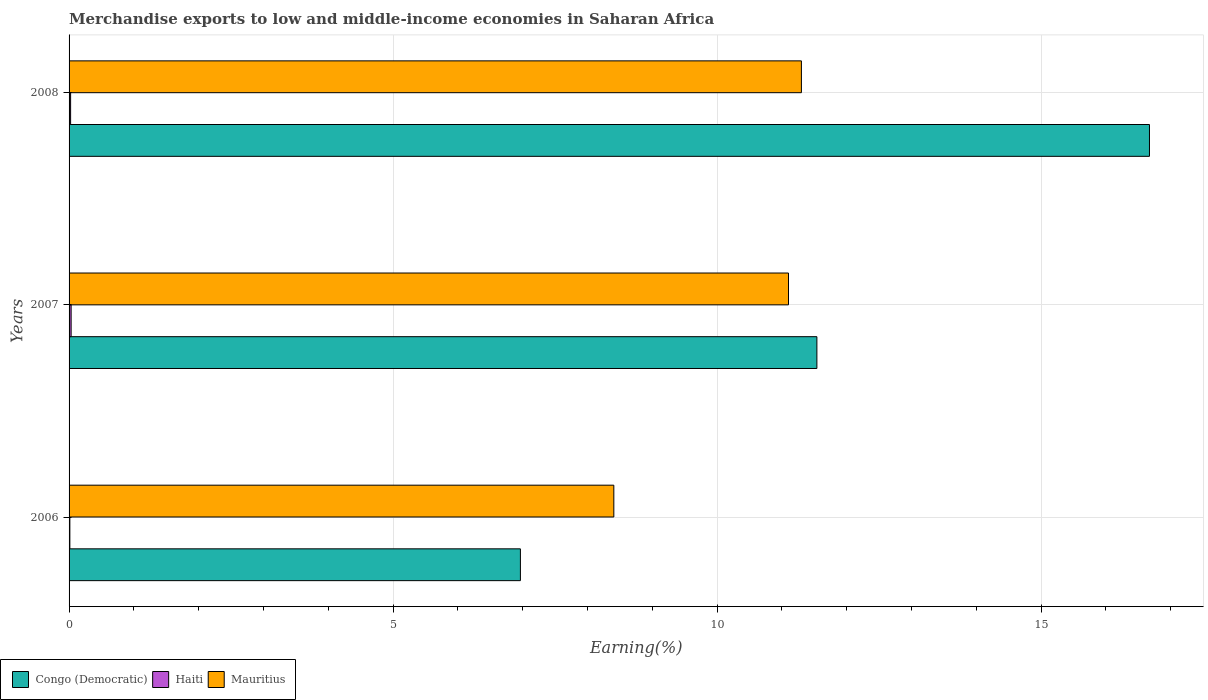Are the number of bars on each tick of the Y-axis equal?
Provide a succinct answer. Yes. How many bars are there on the 1st tick from the bottom?
Offer a very short reply. 3. What is the label of the 3rd group of bars from the top?
Make the answer very short. 2006. In how many cases, is the number of bars for a given year not equal to the number of legend labels?
Ensure brevity in your answer.  0. What is the percentage of amount earned from merchandise exports in Congo (Democratic) in 2008?
Your response must be concise. 16.67. Across all years, what is the maximum percentage of amount earned from merchandise exports in Mauritius?
Keep it short and to the point. 11.3. Across all years, what is the minimum percentage of amount earned from merchandise exports in Mauritius?
Offer a very short reply. 8.41. In which year was the percentage of amount earned from merchandise exports in Haiti maximum?
Give a very brief answer. 2007. In which year was the percentage of amount earned from merchandise exports in Haiti minimum?
Provide a succinct answer. 2006. What is the total percentage of amount earned from merchandise exports in Haiti in the graph?
Offer a very short reply. 0.07. What is the difference between the percentage of amount earned from merchandise exports in Congo (Democratic) in 2007 and that in 2008?
Your response must be concise. -5.13. What is the difference between the percentage of amount earned from merchandise exports in Mauritius in 2006 and the percentage of amount earned from merchandise exports in Haiti in 2008?
Offer a terse response. 8.38. What is the average percentage of amount earned from merchandise exports in Mauritius per year?
Make the answer very short. 10.27. In the year 2008, what is the difference between the percentage of amount earned from merchandise exports in Mauritius and percentage of amount earned from merchandise exports in Congo (Democratic)?
Make the answer very short. -5.37. In how many years, is the percentage of amount earned from merchandise exports in Haiti greater than 15 %?
Offer a terse response. 0. What is the ratio of the percentage of amount earned from merchandise exports in Congo (Democratic) in 2007 to that in 2008?
Offer a terse response. 0.69. Is the percentage of amount earned from merchandise exports in Mauritius in 2006 less than that in 2008?
Your answer should be compact. Yes. Is the difference between the percentage of amount earned from merchandise exports in Mauritius in 2006 and 2007 greater than the difference between the percentage of amount earned from merchandise exports in Congo (Democratic) in 2006 and 2007?
Keep it short and to the point. Yes. What is the difference between the highest and the second highest percentage of amount earned from merchandise exports in Congo (Democratic)?
Your response must be concise. 5.13. What is the difference between the highest and the lowest percentage of amount earned from merchandise exports in Congo (Democratic)?
Provide a succinct answer. 9.71. In how many years, is the percentage of amount earned from merchandise exports in Congo (Democratic) greater than the average percentage of amount earned from merchandise exports in Congo (Democratic) taken over all years?
Provide a succinct answer. 1. Is the sum of the percentage of amount earned from merchandise exports in Mauritius in 2007 and 2008 greater than the maximum percentage of amount earned from merchandise exports in Congo (Democratic) across all years?
Provide a succinct answer. Yes. What does the 2nd bar from the top in 2006 represents?
Your answer should be very brief. Haiti. What does the 1st bar from the bottom in 2006 represents?
Make the answer very short. Congo (Democratic). Are all the bars in the graph horizontal?
Offer a very short reply. Yes. Are the values on the major ticks of X-axis written in scientific E-notation?
Offer a terse response. No. Does the graph contain any zero values?
Your response must be concise. No. Does the graph contain grids?
Your answer should be compact. Yes. Where does the legend appear in the graph?
Your response must be concise. Bottom left. How many legend labels are there?
Your response must be concise. 3. What is the title of the graph?
Give a very brief answer. Merchandise exports to low and middle-income economies in Saharan Africa. What is the label or title of the X-axis?
Ensure brevity in your answer.  Earning(%). What is the Earning(%) in Congo (Democratic) in 2006?
Your answer should be compact. 6.96. What is the Earning(%) of Haiti in 2006?
Make the answer very short. 0.01. What is the Earning(%) of Mauritius in 2006?
Your answer should be very brief. 8.41. What is the Earning(%) of Congo (Democratic) in 2007?
Make the answer very short. 11.54. What is the Earning(%) in Haiti in 2007?
Make the answer very short. 0.03. What is the Earning(%) of Mauritius in 2007?
Your answer should be very brief. 11.1. What is the Earning(%) in Congo (Democratic) in 2008?
Ensure brevity in your answer.  16.67. What is the Earning(%) in Haiti in 2008?
Your response must be concise. 0.02. What is the Earning(%) in Mauritius in 2008?
Give a very brief answer. 11.3. Across all years, what is the maximum Earning(%) of Congo (Democratic)?
Offer a terse response. 16.67. Across all years, what is the maximum Earning(%) of Haiti?
Make the answer very short. 0.03. Across all years, what is the maximum Earning(%) of Mauritius?
Your answer should be very brief. 11.3. Across all years, what is the minimum Earning(%) of Congo (Democratic)?
Your answer should be very brief. 6.96. Across all years, what is the minimum Earning(%) of Haiti?
Provide a succinct answer. 0.01. Across all years, what is the minimum Earning(%) of Mauritius?
Ensure brevity in your answer.  8.41. What is the total Earning(%) in Congo (Democratic) in the graph?
Give a very brief answer. 35.18. What is the total Earning(%) of Haiti in the graph?
Your answer should be compact. 0.07. What is the total Earning(%) in Mauritius in the graph?
Ensure brevity in your answer.  30.81. What is the difference between the Earning(%) in Congo (Democratic) in 2006 and that in 2007?
Your response must be concise. -4.58. What is the difference between the Earning(%) in Haiti in 2006 and that in 2007?
Provide a short and direct response. -0.02. What is the difference between the Earning(%) of Mauritius in 2006 and that in 2007?
Provide a short and direct response. -2.7. What is the difference between the Earning(%) of Congo (Democratic) in 2006 and that in 2008?
Your response must be concise. -9.71. What is the difference between the Earning(%) in Haiti in 2006 and that in 2008?
Offer a very short reply. -0.01. What is the difference between the Earning(%) of Mauritius in 2006 and that in 2008?
Give a very brief answer. -2.89. What is the difference between the Earning(%) in Congo (Democratic) in 2007 and that in 2008?
Provide a short and direct response. -5.13. What is the difference between the Earning(%) of Haiti in 2007 and that in 2008?
Keep it short and to the point. 0.01. What is the difference between the Earning(%) in Mauritius in 2007 and that in 2008?
Your answer should be very brief. -0.2. What is the difference between the Earning(%) of Congo (Democratic) in 2006 and the Earning(%) of Haiti in 2007?
Provide a succinct answer. 6.93. What is the difference between the Earning(%) in Congo (Democratic) in 2006 and the Earning(%) in Mauritius in 2007?
Your answer should be compact. -4.14. What is the difference between the Earning(%) of Haiti in 2006 and the Earning(%) of Mauritius in 2007?
Provide a succinct answer. -11.09. What is the difference between the Earning(%) in Congo (Democratic) in 2006 and the Earning(%) in Haiti in 2008?
Your answer should be very brief. 6.94. What is the difference between the Earning(%) of Congo (Democratic) in 2006 and the Earning(%) of Mauritius in 2008?
Ensure brevity in your answer.  -4.34. What is the difference between the Earning(%) in Haiti in 2006 and the Earning(%) in Mauritius in 2008?
Provide a succinct answer. -11.29. What is the difference between the Earning(%) in Congo (Democratic) in 2007 and the Earning(%) in Haiti in 2008?
Your answer should be compact. 11.52. What is the difference between the Earning(%) in Congo (Democratic) in 2007 and the Earning(%) in Mauritius in 2008?
Provide a short and direct response. 0.24. What is the difference between the Earning(%) of Haiti in 2007 and the Earning(%) of Mauritius in 2008?
Your answer should be very brief. -11.27. What is the average Earning(%) of Congo (Democratic) per year?
Your answer should be very brief. 11.73. What is the average Earning(%) of Haiti per year?
Give a very brief answer. 0.02. What is the average Earning(%) of Mauritius per year?
Provide a short and direct response. 10.27. In the year 2006, what is the difference between the Earning(%) of Congo (Democratic) and Earning(%) of Haiti?
Keep it short and to the point. 6.95. In the year 2006, what is the difference between the Earning(%) in Congo (Democratic) and Earning(%) in Mauritius?
Your answer should be very brief. -1.44. In the year 2006, what is the difference between the Earning(%) in Haiti and Earning(%) in Mauritius?
Make the answer very short. -8.39. In the year 2007, what is the difference between the Earning(%) of Congo (Democratic) and Earning(%) of Haiti?
Keep it short and to the point. 11.51. In the year 2007, what is the difference between the Earning(%) of Congo (Democratic) and Earning(%) of Mauritius?
Offer a terse response. 0.44. In the year 2007, what is the difference between the Earning(%) in Haiti and Earning(%) in Mauritius?
Offer a terse response. -11.07. In the year 2008, what is the difference between the Earning(%) of Congo (Democratic) and Earning(%) of Haiti?
Your answer should be very brief. 16.65. In the year 2008, what is the difference between the Earning(%) of Congo (Democratic) and Earning(%) of Mauritius?
Offer a terse response. 5.37. In the year 2008, what is the difference between the Earning(%) in Haiti and Earning(%) in Mauritius?
Ensure brevity in your answer.  -11.28. What is the ratio of the Earning(%) in Congo (Democratic) in 2006 to that in 2007?
Provide a succinct answer. 0.6. What is the ratio of the Earning(%) in Haiti in 2006 to that in 2007?
Offer a terse response. 0.38. What is the ratio of the Earning(%) of Mauritius in 2006 to that in 2007?
Your answer should be compact. 0.76. What is the ratio of the Earning(%) of Congo (Democratic) in 2006 to that in 2008?
Give a very brief answer. 0.42. What is the ratio of the Earning(%) of Haiti in 2006 to that in 2008?
Your response must be concise. 0.51. What is the ratio of the Earning(%) in Mauritius in 2006 to that in 2008?
Your response must be concise. 0.74. What is the ratio of the Earning(%) of Congo (Democratic) in 2007 to that in 2008?
Give a very brief answer. 0.69. What is the ratio of the Earning(%) in Haiti in 2007 to that in 2008?
Offer a terse response. 1.33. What is the ratio of the Earning(%) of Mauritius in 2007 to that in 2008?
Your response must be concise. 0.98. What is the difference between the highest and the second highest Earning(%) in Congo (Democratic)?
Ensure brevity in your answer.  5.13. What is the difference between the highest and the second highest Earning(%) in Haiti?
Offer a very short reply. 0.01. What is the difference between the highest and the second highest Earning(%) of Mauritius?
Offer a very short reply. 0.2. What is the difference between the highest and the lowest Earning(%) of Congo (Democratic)?
Offer a very short reply. 9.71. What is the difference between the highest and the lowest Earning(%) in Haiti?
Keep it short and to the point. 0.02. What is the difference between the highest and the lowest Earning(%) in Mauritius?
Your answer should be compact. 2.89. 